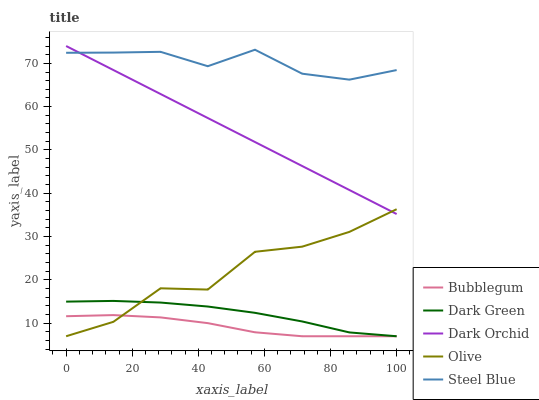Does Bubblegum have the minimum area under the curve?
Answer yes or no. Yes. Does Steel Blue have the maximum area under the curve?
Answer yes or no. Yes. Does Dark Orchid have the minimum area under the curve?
Answer yes or no. No. Does Dark Orchid have the maximum area under the curve?
Answer yes or no. No. Is Dark Orchid the smoothest?
Answer yes or no. Yes. Is Olive the roughest?
Answer yes or no. Yes. Is Steel Blue the smoothest?
Answer yes or no. No. Is Steel Blue the roughest?
Answer yes or no. No. Does Dark Orchid have the lowest value?
Answer yes or no. No. Does Steel Blue have the highest value?
Answer yes or no. No. Is Dark Green less than Dark Orchid?
Answer yes or no. Yes. Is Steel Blue greater than Dark Green?
Answer yes or no. Yes. Does Dark Green intersect Dark Orchid?
Answer yes or no. No. 